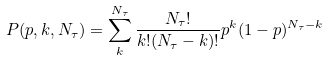<formula> <loc_0><loc_0><loc_500><loc_500>P ( p , k , N _ { \tau } ) = \sum _ { k } ^ { N _ { \tau } } \frac { N _ { \tau } ! } { k ! ( N _ { \tau } - k ) ! } p ^ { k } ( 1 - p ) ^ { N _ { \tau } - k }</formula> 